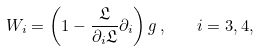Convert formula to latex. <formula><loc_0><loc_0><loc_500><loc_500>W _ { i } = \left ( 1 - \frac { \mathfrak { L } } { \partial _ { i } \mathfrak { L } } \partial _ { i } \right ) g \, , \quad i = 3 , 4 ,</formula> 